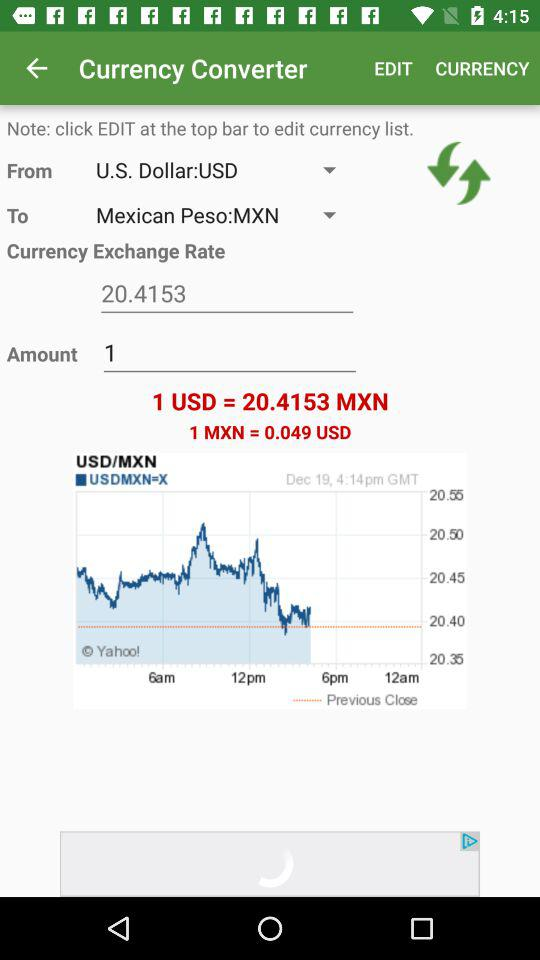What is the amount? The amount is 1. 